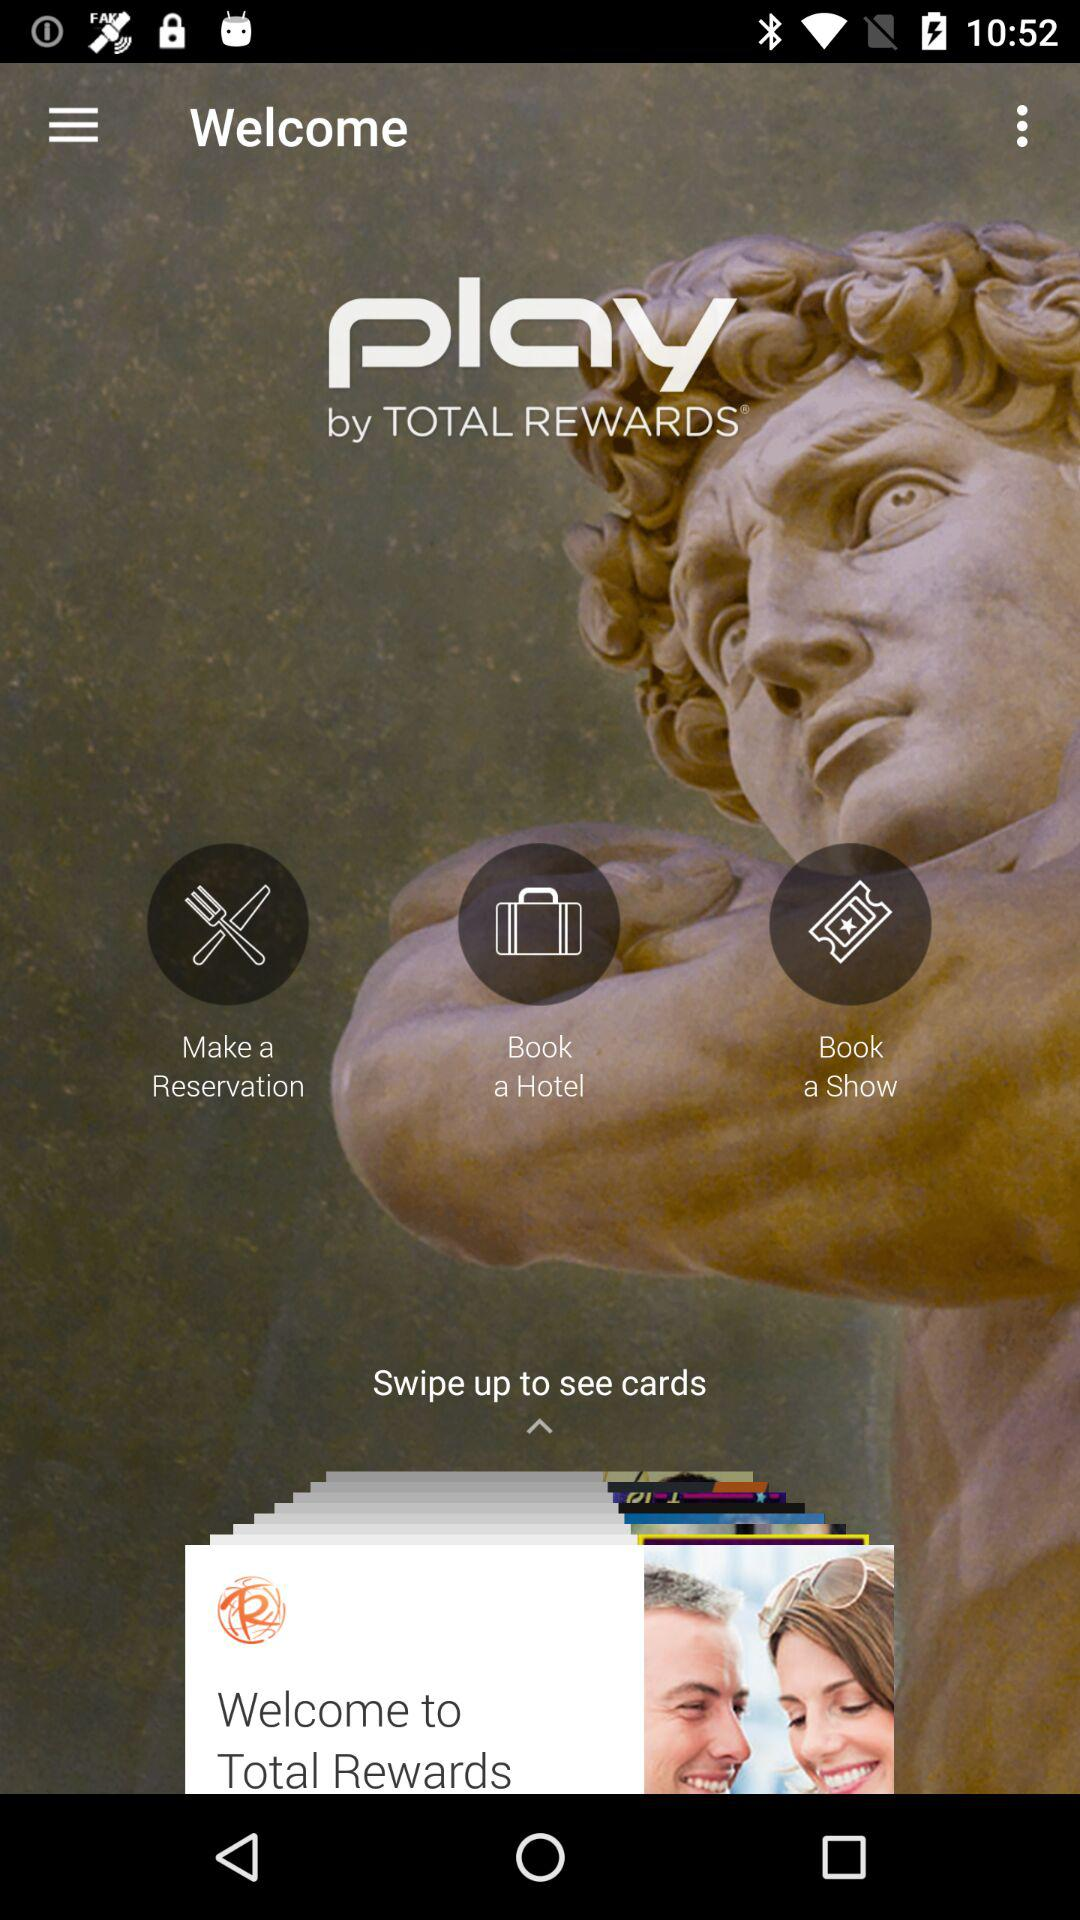Which hotel is booked?
When the provided information is insufficient, respond with <no answer>. <no answer> 